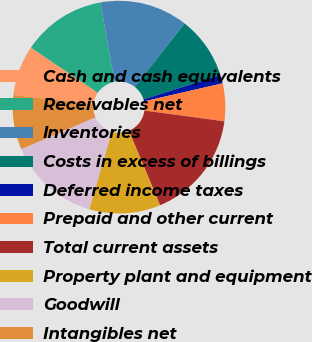Convert chart to OTSL. <chart><loc_0><loc_0><loc_500><loc_500><pie_chart><fcel>Cash and cash equivalents<fcel>Receivables net<fcel>Inventories<fcel>Costs in excess of billings<fcel>Deferred income taxes<fcel>Prepaid and other current<fcel>Total current assets<fcel>Property plant and equipment<fcel>Goodwill<fcel>Intangibles net<nl><fcel>7.64%<fcel>12.74%<fcel>13.37%<fcel>9.55%<fcel>1.28%<fcel>5.73%<fcel>16.56%<fcel>10.83%<fcel>14.01%<fcel>8.28%<nl></chart> 